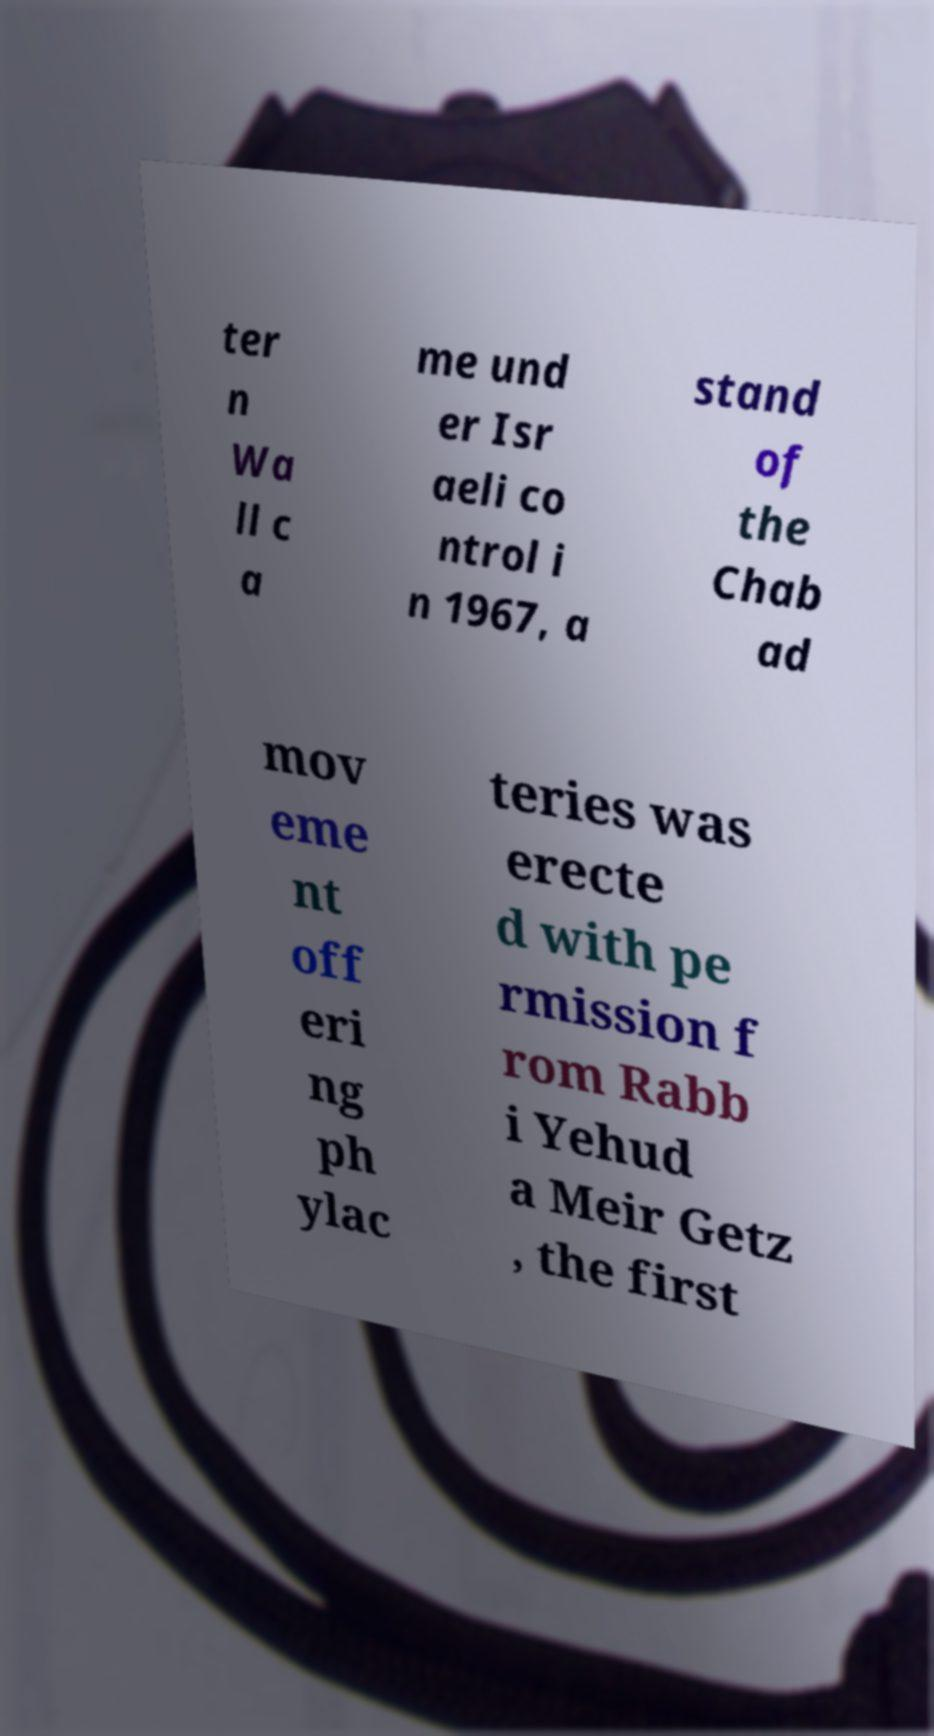Could you assist in decoding the text presented in this image and type it out clearly? ter n Wa ll c a me und er Isr aeli co ntrol i n 1967, a stand of the Chab ad mov eme nt off eri ng ph ylac teries was erecte d with pe rmission f rom Rabb i Yehud a Meir Getz , the first 